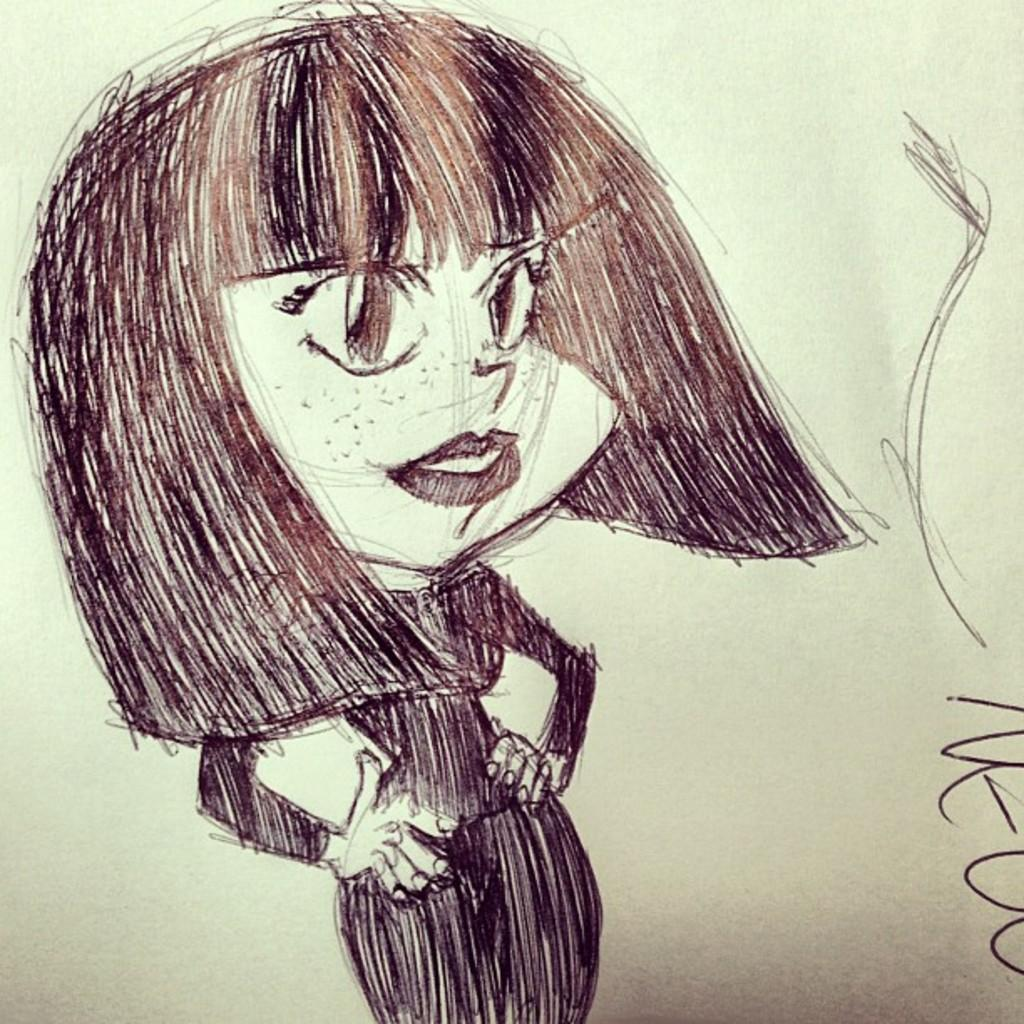What is the main subject of the image? The main subject of the image is a girl. What is the style of the image? The image is a sketch painting. What color scheme is used in the image? The color of the image is black and white. How many trees can be seen in the image? There are no trees visible in the image, as it is a sketch painting of a girl. What type of growth is depicted in the image? There is no growth depicted in the image, as it is a sketch painting of a girl. 